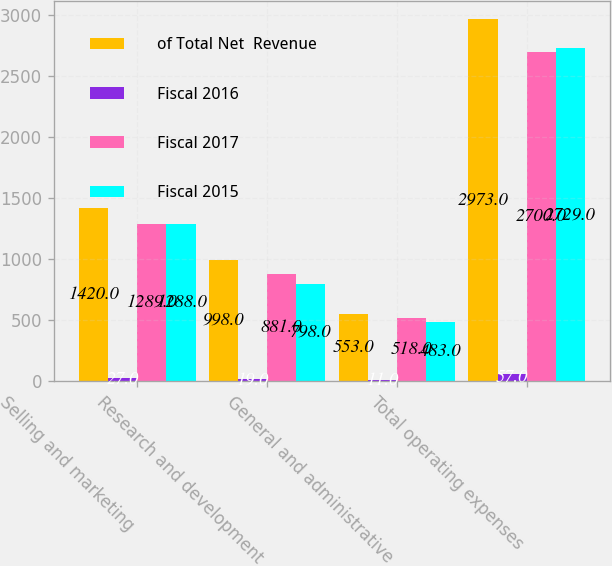Convert chart. <chart><loc_0><loc_0><loc_500><loc_500><stacked_bar_chart><ecel><fcel>Selling and marketing<fcel>Research and development<fcel>General and administrative<fcel>Total operating expenses<nl><fcel>of Total Net  Revenue<fcel>1420<fcel>998<fcel>553<fcel>2973<nl><fcel>Fiscal 2016<fcel>27<fcel>19<fcel>11<fcel>57<nl><fcel>Fiscal 2017<fcel>1289<fcel>881<fcel>518<fcel>2700<nl><fcel>Fiscal 2015<fcel>1288<fcel>798<fcel>483<fcel>2729<nl></chart> 